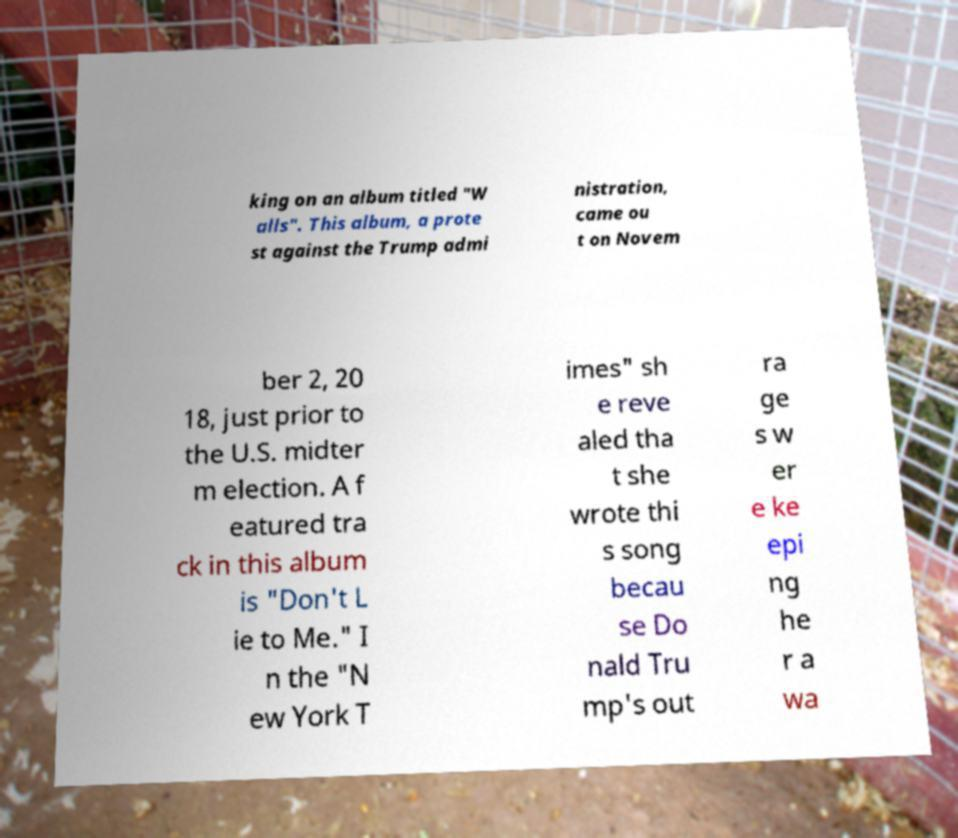Please identify and transcribe the text found in this image. king on an album titled "W alls". This album, a prote st against the Trump admi nistration, came ou t on Novem ber 2, 20 18, just prior to the U.S. midter m election. A f eatured tra ck in this album is "Don't L ie to Me." I n the "N ew York T imes" sh e reve aled tha t she wrote thi s song becau se Do nald Tru mp's out ra ge s w er e ke epi ng he r a wa 